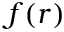<formula> <loc_0><loc_0><loc_500><loc_500>f ( r )</formula> 